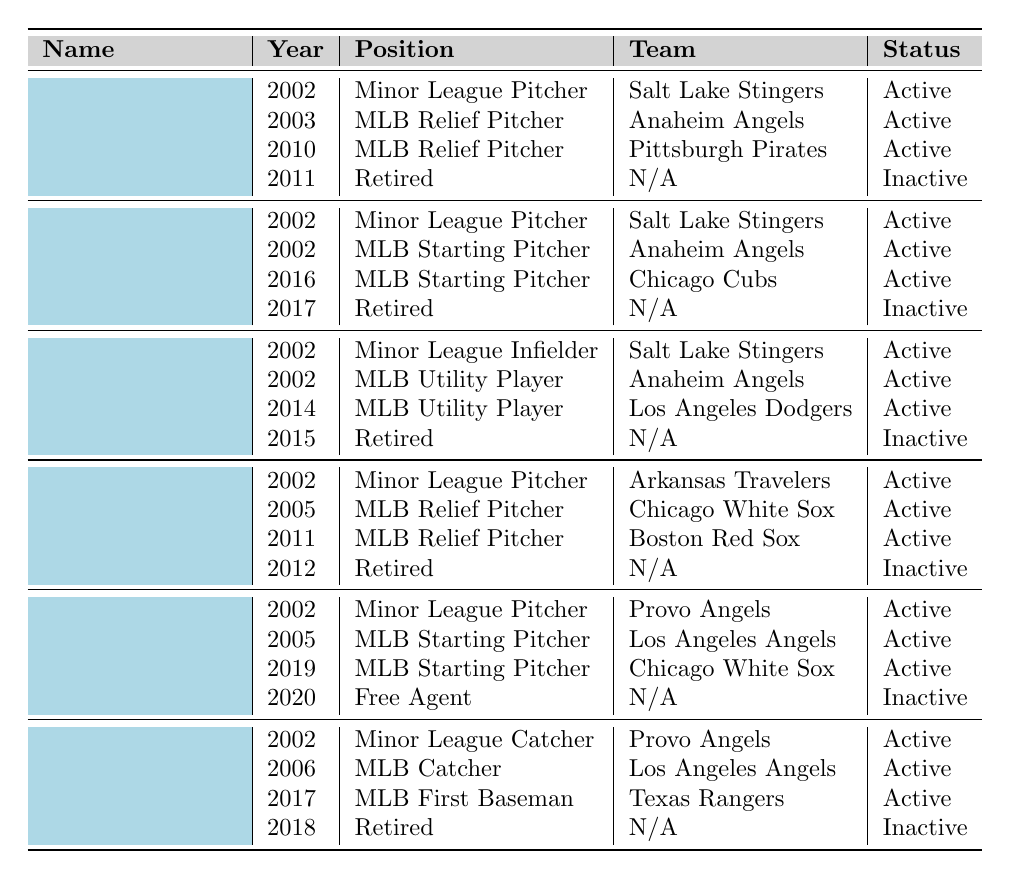What position did Bobby Jenks play in 2005? In the table, under Bobby Jenks' career path, the entry for 2005 shows he was an MLB Relief Pitcher.
Answer: MLB Relief Pitcher How many players transitioned from minor league to MLB in 2002? The table shows that all six players listed participated in 2002, and each one had a position as a Minor League player that year. Additionally, all but one (John Lackey) went to MLB that same year. Hence, there were 5 players that made the transition that year.
Answer: 5 Which player had the longest active career in MLB? Looking through the career paths, Ervin Santana made his MLB debut in 2005 and was active until 2019 before becoming a free agent. This counts as 14 active years, which is the longest compared to others who retired earlier.
Answer: Ervin Santana Did any of the players retire after 2017? By checking the retirement years listed in the table, both John Lackey and Mike Napoli retired in 2017 or after, making the answer yes.
Answer: Yes How many years did Brendan Donnelly play before retiring? Brendan Donnelly was active from 2002 to 2011, which totals 10 years. The years 2002, 2003, 2010, and 2011 count as individual active years until he retired.
Answer: 10 years Which player played for the longest number of teams during their career? If we examine the career paths, Chone Figgins and Mike Napoli each played for two teams in MLB as listed in the table, while others played for one or two teams, so neither had a clear edge based on available data. However, since multiple players have played for two teams, it implies they're equal.
Answer: Chone Figgins and Mike Napoli What was the last team Brendan Donnelly played for? The last team listed for Brendan Donnelly in the table is the Pittsburgh Pirates for the year 2010.
Answer: Pittsburgh Pirates How many total years did John Lackey spend in MLB? John Lackey was in MLB from 2002, appearing as both a Minor League Pitcher and MLB Starting Pitcher until his retirement in 2017. This counts as 15 active years in total across various roles.
Answer: 15 years Did any players make their MLB debuts in the same year they were in minor league? By referring to the table, Brendan Donnelly, John Lackey, Chone Figgins, and Bobby Jenks debuted in 2002 after being a minor league player that same year. This indicates that yes, these players made that transition in the same year.
Answer: Yes What position did Mike Napoli play when he retired? According to the table, Mike Napoli retired in 2018 as an MLB First Baseman for the Texas Rangers, which is the last position listed.
Answer: MLB First Baseman Who was the last active player from these teammates? The latest year mentioned for any player maintaining active status is 2020, when Ervin Santana was listed as a Free Agent, making him the last active player.
Answer: Ervin Santana 